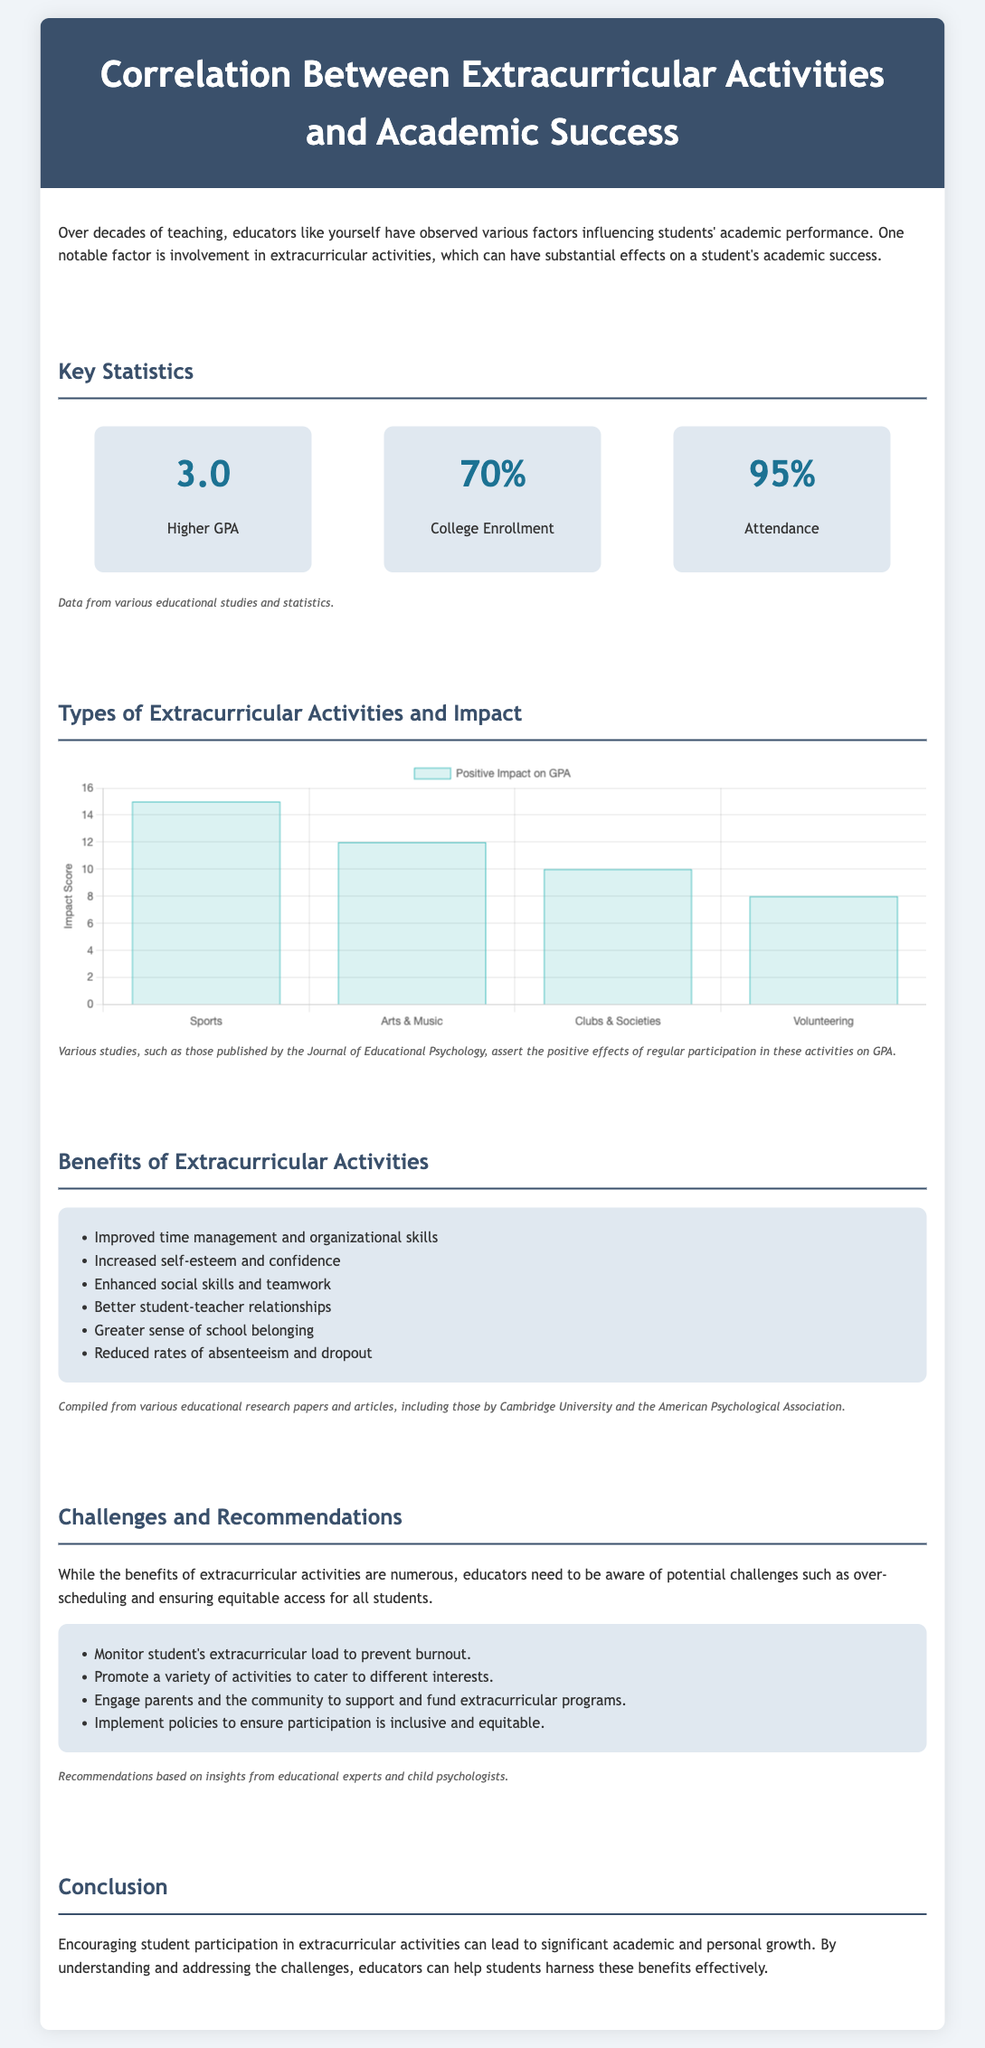what is the average higher GPA reported? The document states a higher GPA of 3.0, which indicates the average reported in correlation with extracurricular activities.
Answer: 3.0 what percentage of students are reported to enroll in college? According to the infographic, 70% of students involved in extracurricular activities enroll in college, illustrating a significant correlation.
Answer: 70% what is the attendance percentage among students participating in extracurricular activities? The document notes that the attendance rate is 95%, showcasing a positive outcome related to extracurricular involvement.
Answer: 95% which extracurricular activity has the highest positive impact on GPA? The chart in the document shows that Sports have the highest positive impact score of 15 on GPA among the listed activities.
Answer: Sports how many positive impact points are attributed to Arts & Music? The document states that Arts & Music have a positive impact score of 12 on GPA, indicating their contribution to academic success.
Answer: 12 what key benefit is noted related to social skills? The document lists "Enhanced social skills and teamwork" as a benefit of participating in extracurricular activities, highlighting its importance in academic environments.
Answer: Enhanced social skills what is the main challenge mentioned regarding extracurricular activities? The infographic points out "over-scheduling" as a potential challenge educators need to be aware of concerning student involvement in extracurricular activities.
Answer: over-scheduling how many types of extracurricular activities are mentioned in the chart? The chart includes four types of activities: Sports, Arts & Music, Clubs & Societies, and Volunteering, indicating a variety of engagement options for students.
Answer: Four 